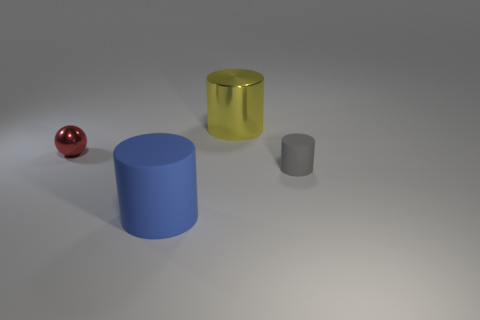Is the small cylinder made of the same material as the cylinder to the left of the shiny cylinder?
Make the answer very short. Yes. What is the material of the tiny object that is right of the big cylinder that is in front of the small red ball?
Give a very brief answer. Rubber. Are there more large cylinders behind the yellow metallic cylinder than tiny spheres?
Offer a terse response. No. Are any gray things visible?
Keep it short and to the point. Yes. There is a thing that is behind the small red metal sphere; what is its color?
Offer a terse response. Yellow. What is the material of the blue cylinder that is the same size as the yellow metal cylinder?
Provide a short and direct response. Rubber. What number of other objects are the same material as the red thing?
Offer a terse response. 1. The cylinder that is behind the blue cylinder and in front of the large metallic object is what color?
Offer a terse response. Gray. What number of objects are tiny objects left of the big blue matte cylinder or big yellow metal cylinders?
Keep it short and to the point. 2. What number of other things are the same color as the small cylinder?
Give a very brief answer. 0. 